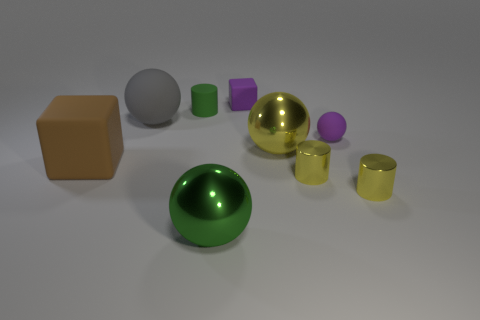There is a big object that is the same color as the rubber cylinder; what is it made of?
Keep it short and to the point. Metal. What number of cylinders are small blue objects or small things?
Provide a short and direct response. 3. How big is the gray matte sphere?
Offer a very short reply. Large. There is a tiny block; what number of large spheres are in front of it?
Offer a very short reply. 3. There is a block that is in front of the tiny object that is behind the small green matte cylinder; what size is it?
Ensure brevity in your answer.  Large. There is a green object that is in front of the brown block; is it the same shape as the tiny rubber thing on the left side of the large green metal sphere?
Give a very brief answer. No. There is a gray thing that is to the left of the rubber cube that is right of the gray sphere; what is its shape?
Your answer should be compact. Sphere. What is the size of the ball that is in front of the tiny rubber sphere and on the right side of the purple rubber block?
Make the answer very short. Large. Is the shape of the gray object the same as the small matte object that is in front of the tiny green rubber cylinder?
Provide a short and direct response. Yes. The gray object that is the same shape as the big yellow thing is what size?
Make the answer very short. Large. 